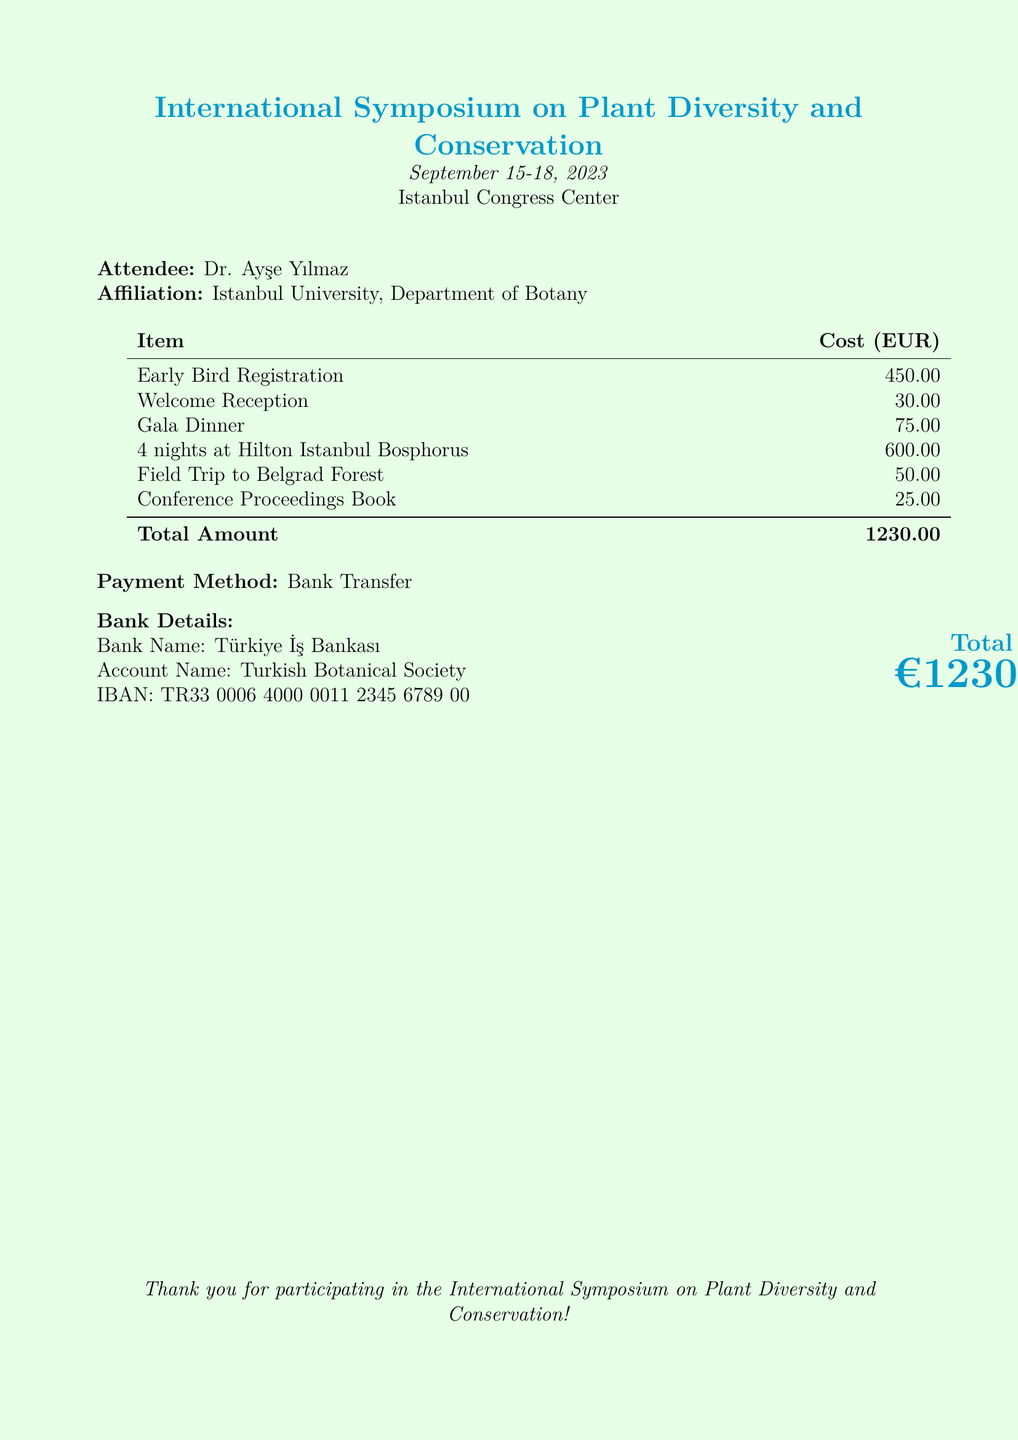What is the total amount due? The total amount is listed at the bottom of the bill as the total cost for the conference fees and accommodation.
Answer: €1230.00 What is the early bird registration fee? The early bird registration fee is specified in the itemized list of costs.
Answer: 450.00 How many nights of accommodation are included? The document states that the attendee is charged for 4 nights at the hotel.
Answer: 4 nights What is the cost of the field trip? The cost for the field trip to Belgrad Forest is provided in the itemized list.
Answer: 50.00 What is the venue for the symposium? The venue is mentioned at the beginning of the document.
Answer: Istanbul Congress Center Who is the attendee? The name of the attendee is clearly stated in the document.
Answer: Dr. Ayşe Yılmaz What is the payment method specified? The method of payment is detailed in the document above the bank details section.
Answer: Bank Transfer What is the name of the bank? The bank that is specified for the payment is mentioned in the bank details section.
Answer: Türkiye İş Bankası How much was the gala dinner? The cost for the gala dinner is included in the itemized costs.
Answer: 75.00 